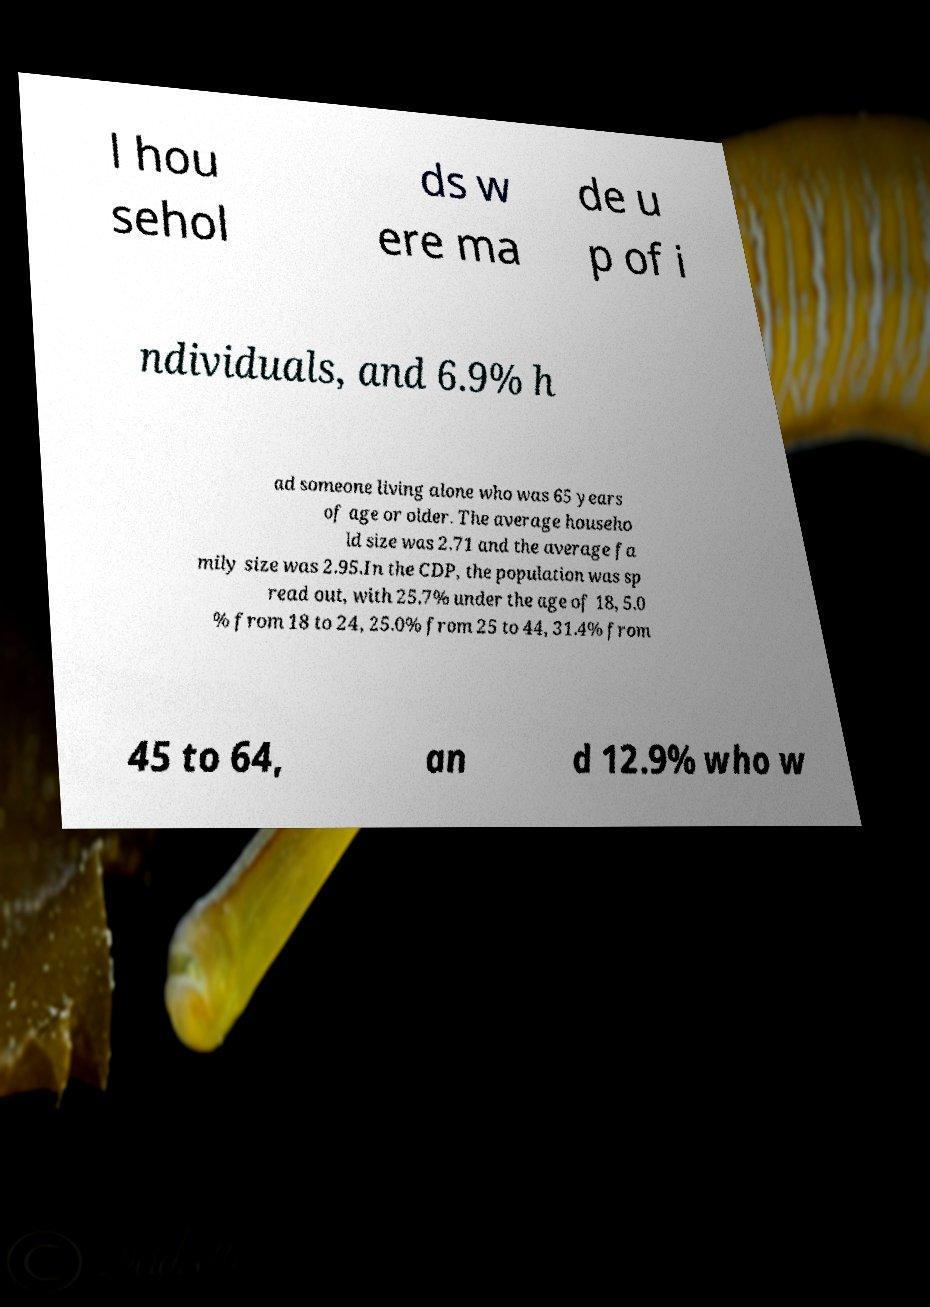Could you assist in decoding the text presented in this image and type it out clearly? l hou sehol ds w ere ma de u p of i ndividuals, and 6.9% h ad someone living alone who was 65 years of age or older. The average househo ld size was 2.71 and the average fa mily size was 2.95.In the CDP, the population was sp read out, with 25.7% under the age of 18, 5.0 % from 18 to 24, 25.0% from 25 to 44, 31.4% from 45 to 64, an d 12.9% who w 